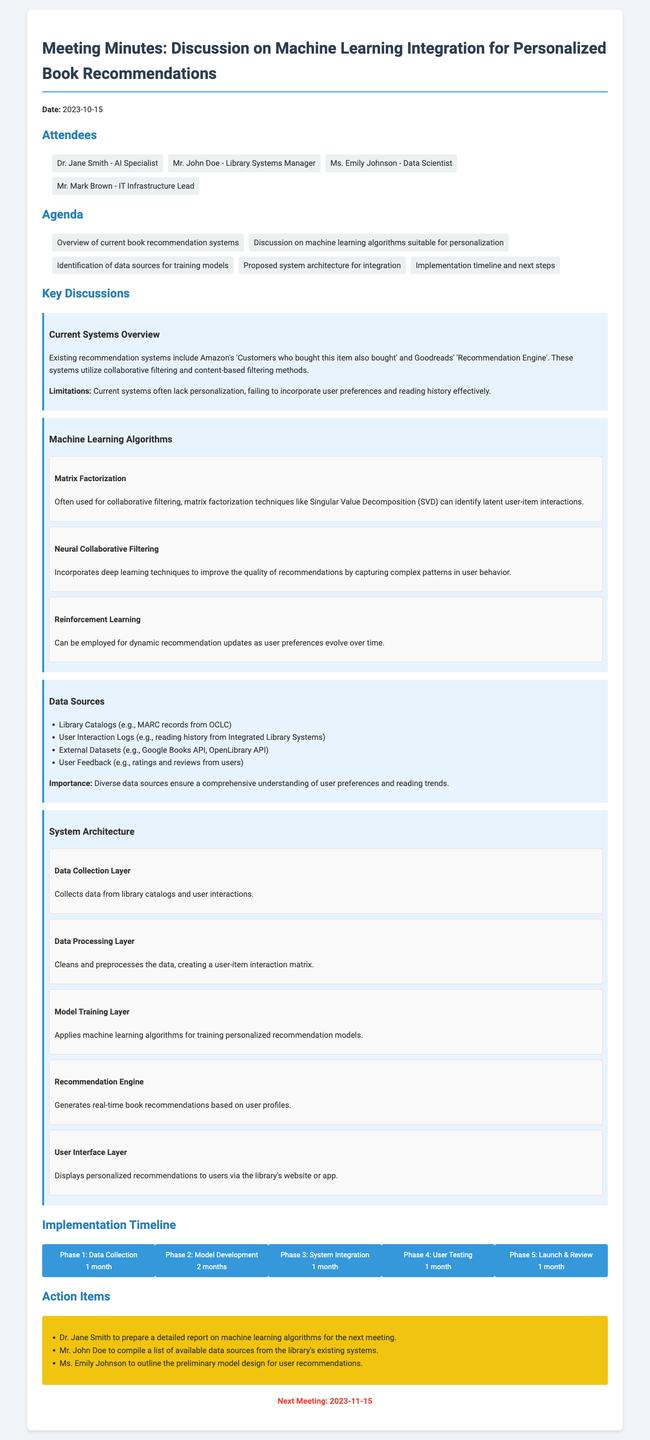What is the date of the meeting? The date is clearly stated at the beginning of the document.
Answer: 2023-10-15 Who is the AI Specialist attending the meeting? The attendees section lists Dr. Jane Smith as the AI Specialist.
Answer: Dr. Jane Smith What is one of the current systems mentioned for recommendations? The document lists examples of existing recommendation systems.
Answer: Goodreads' 'Recommendation Engine' What type of machine learning algorithm is used for dynamic recommendation updates? The discussion on algorithms mentions this specific technique.
Answer: Reinforcement Learning How many phases are there in the implementation timeline? The timeline section depicts multiple phases.
Answer: 5 What will Mr. John Doe do as an action item? The action items outline specific responsibilities for attendees.
Answer: Compile a list of available data sources What layer collects data from library catalogs? The system architecture section describes its components.
Answer: Data Collection Layer Which phase includes user testing and how long will it take? The timeline specifies actions and durations for each phase.
Answer: Phase 4: User Testing - 1 month What is the next meeting date? The conclusion of the document specifies the date of the next meeting.
Answer: 2023-11-15 